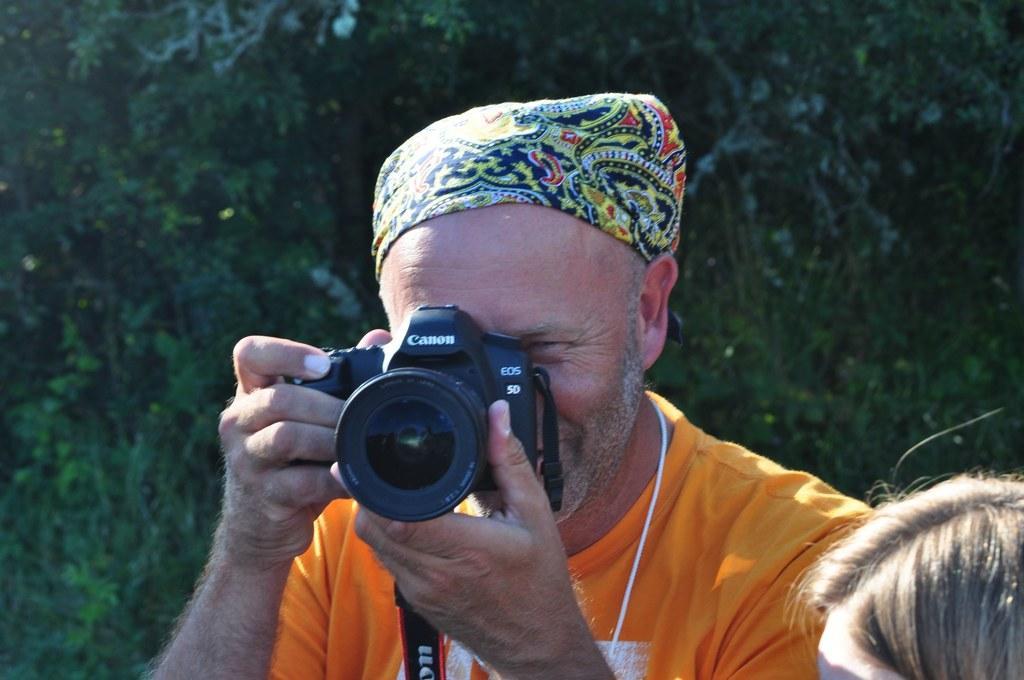In one or two sentences, can you explain what this image depicts? In picture there is one person in the middle. He is wearing orange t-shirt and clicking pictures with the camera and wearing a scarf on his head behind him there are trees and in right corner of the picture one person is there. 